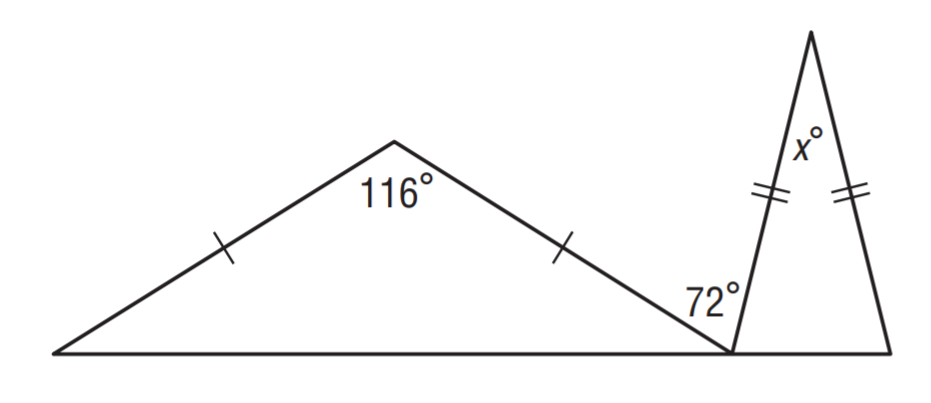Question: Find x.
Choices:
A. 22
B. 28
C. 32
D. 36
Answer with the letter. Answer: B 